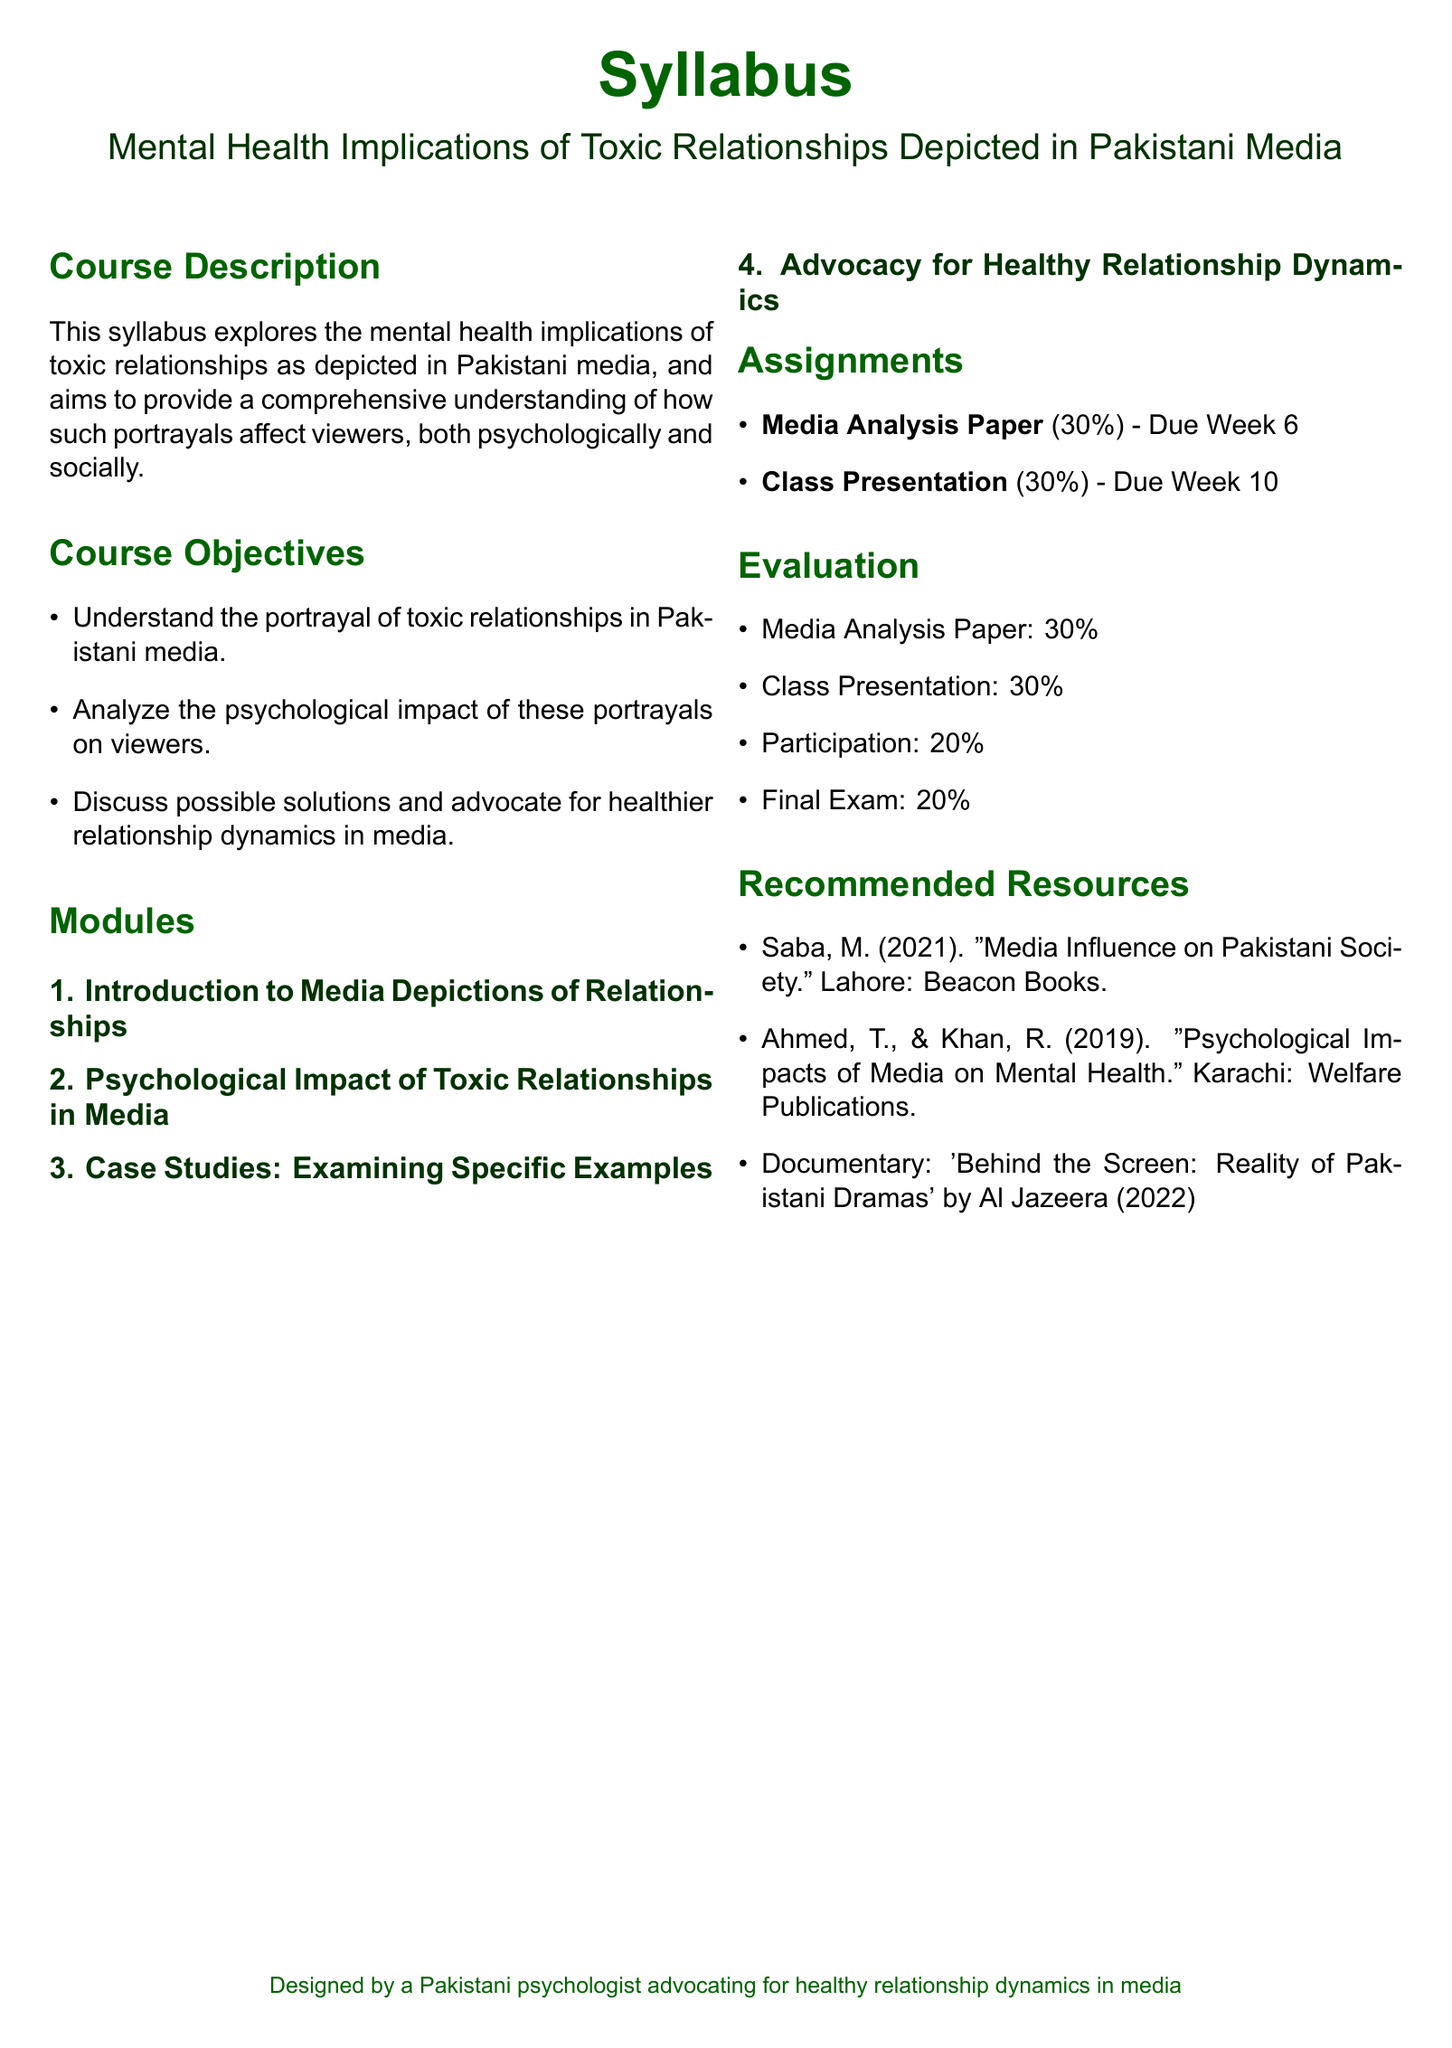What is the title of the syllabus? The title of the syllabus is mentioned in the center at the top of the document.
Answer: Mental Health Implications of Toxic Relationships Depicted in Pakistani Media What percentage does the Media Analysis Paper contribute to the overall evaluation? The percentage contribution of each assignment is detailed in the Evaluation section of the document.
Answer: 30% Who are the authors of the recommended resource titled "Psychological Impacts of Media on Mental Health"? The authors' names are listed in the Recommended Resources section of the document.
Answer: Ahmed, T., & Khan, R What module focuses on examining specific examples of toxic relationships? The modules are listed sequentially, and this one is explicitly stated in the Modules section.
Answer: Case Studies: Examining Specific Examples What is the due date for the Class Presentation assignment? The due date is explicitly mentioned alongside the assignment details in the Assignments section.
Answer: Week 10 What is the total percentage allocated for participation in the evaluation? The Evaluation section lists the contributions of each element; therefore, the total participation percentage is straightforward.
Answer: 20% What is the primary aim of the course as described in the Course Description? It can be found in the first few lines of the Course Description section, summarizing what the course intends to achieve.
Answer: Understanding the portrayal of toxic relationships in Pakistani media What is the document type of this syllabus? The document's type is indicated at the beginning and throughout its structure, typically used in education settings.
Answer: Syllabus 